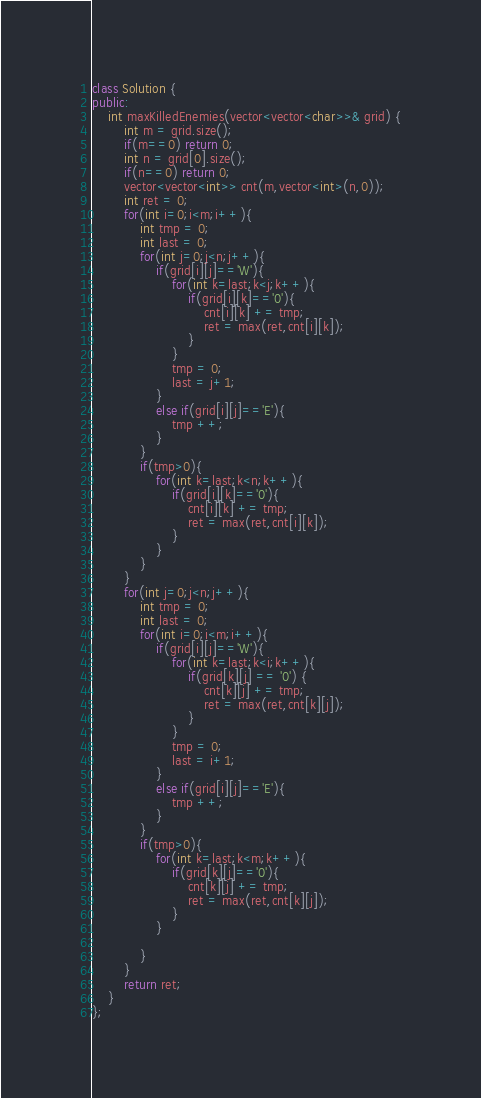<code> <loc_0><loc_0><loc_500><loc_500><_C++_>class Solution {
public:
    int maxKilledEnemies(vector<vector<char>>& grid) {
        int m = grid.size();
        if(m==0) return 0;
        int n = grid[0].size();
        if(n==0) return 0;
        vector<vector<int>> cnt(m,vector<int>(n,0));
        int ret = 0;
        for(int i=0;i<m;i++){
            int tmp = 0;
            int last = 0;
            for(int j=0;j<n;j++){
                if(grid[i][j]=='W'){
                    for(int k=last;k<j;k++){
                        if(grid[i][k]=='0'){
                            cnt[i][k] += tmp;
                            ret = max(ret,cnt[i][k]);
                        }
                    }
                    tmp = 0;
                    last = j+1;
                }
                else if(grid[i][j]=='E'){
                    tmp ++;
                }
            }
            if(tmp>0){
                for(int k=last;k<n;k++){
                    if(grid[i][k]=='0'){
                        cnt[i][k] += tmp;
                        ret = max(ret,cnt[i][k]);
                    }
                }            
            }
        }
        for(int j=0;j<n;j++){
            int tmp = 0;
            int last = 0;
            for(int i=0;i<m;i++){
                if(grid[i][j]=='W'){
                    for(int k=last;k<i;k++){
                        if(grid[k][j] == '0') {
                            cnt[k][j] += tmp;
                            ret = max(ret,cnt[k][j]);
                        }
                    }
                    tmp = 0;
                    last = i+1;
                }
                else if(grid[i][j]=='E'){
                    tmp ++;
                }
            }
            if(tmp>0){
                for(int k=last;k<m;k++){
                    if(grid[k][j]=='0'){
                        cnt[k][j] += tmp;
                        ret = max(ret,cnt[k][j]);
                    }
                } 

            }
        }
        return ret;
    }
};</code> 